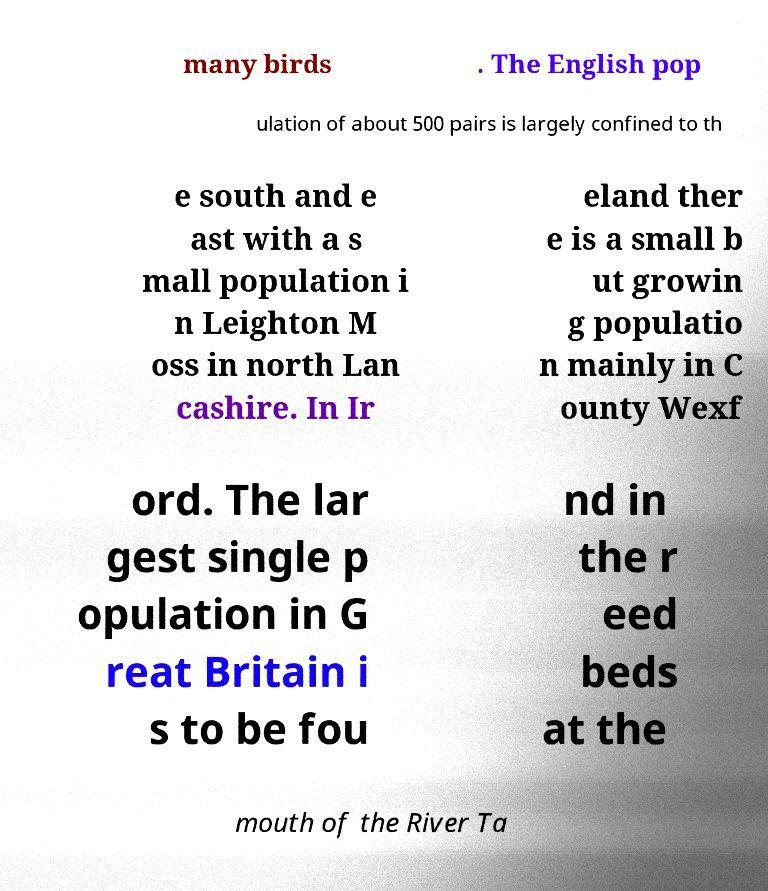I need the written content from this picture converted into text. Can you do that? many birds . The English pop ulation of about 500 pairs is largely confined to th e south and e ast with a s mall population i n Leighton M oss in north Lan cashire. In Ir eland ther e is a small b ut growin g populatio n mainly in C ounty Wexf ord. The lar gest single p opulation in G reat Britain i s to be fou nd in the r eed beds at the mouth of the River Ta 